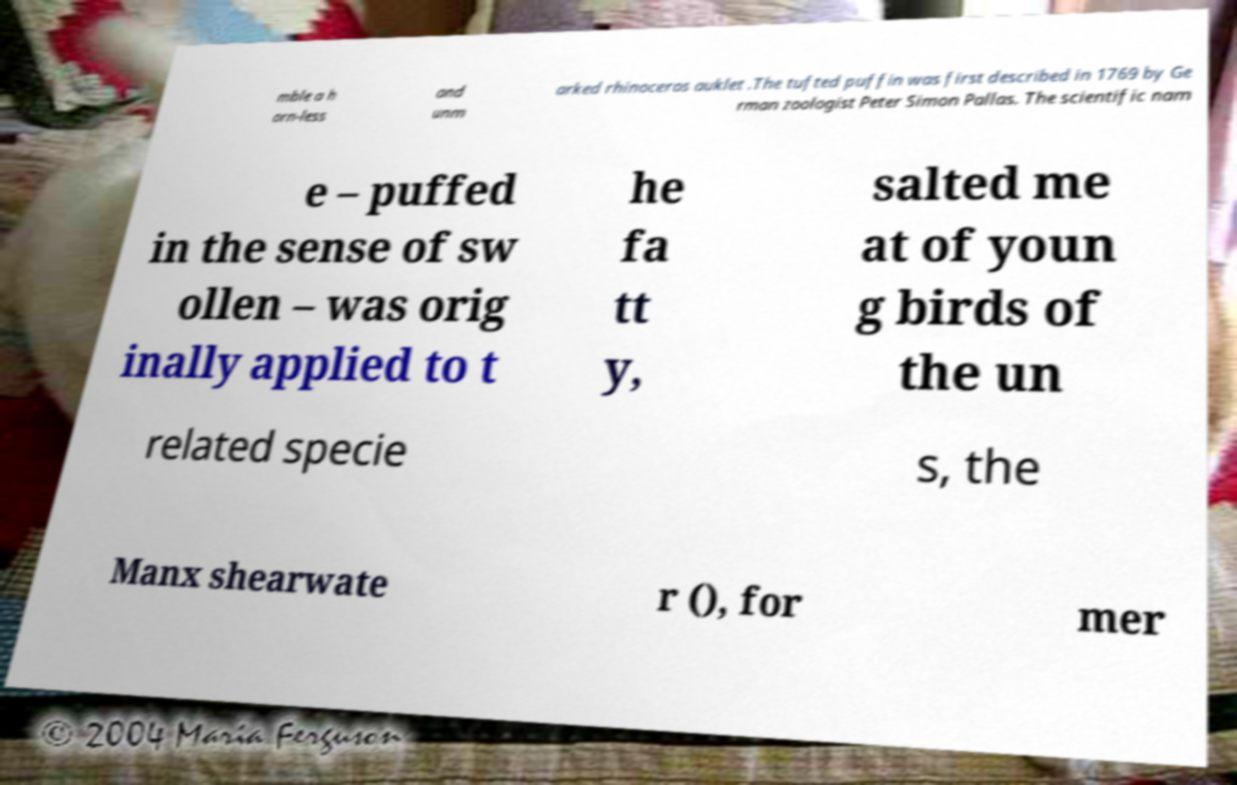I need the written content from this picture converted into text. Can you do that? mble a h orn-less and unm arked rhinoceros auklet .The tufted puffin was first described in 1769 by Ge rman zoologist Peter Simon Pallas. The scientific nam e – puffed in the sense of sw ollen – was orig inally applied to t he fa tt y, salted me at of youn g birds of the un related specie s, the Manx shearwate r (), for mer 